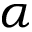<formula> <loc_0><loc_0><loc_500><loc_500>\alpha</formula> 